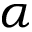<formula> <loc_0><loc_0><loc_500><loc_500>\alpha</formula> 